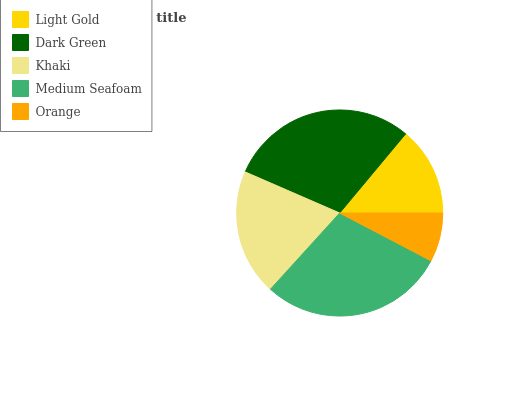Is Orange the minimum?
Answer yes or no. Yes. Is Dark Green the maximum?
Answer yes or no. Yes. Is Khaki the minimum?
Answer yes or no. No. Is Khaki the maximum?
Answer yes or no. No. Is Dark Green greater than Khaki?
Answer yes or no. Yes. Is Khaki less than Dark Green?
Answer yes or no. Yes. Is Khaki greater than Dark Green?
Answer yes or no. No. Is Dark Green less than Khaki?
Answer yes or no. No. Is Khaki the high median?
Answer yes or no. Yes. Is Khaki the low median?
Answer yes or no. Yes. Is Dark Green the high median?
Answer yes or no. No. Is Dark Green the low median?
Answer yes or no. No. 